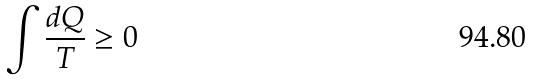<formula> <loc_0><loc_0><loc_500><loc_500>\int \frac { d Q } { T } \geq 0</formula> 